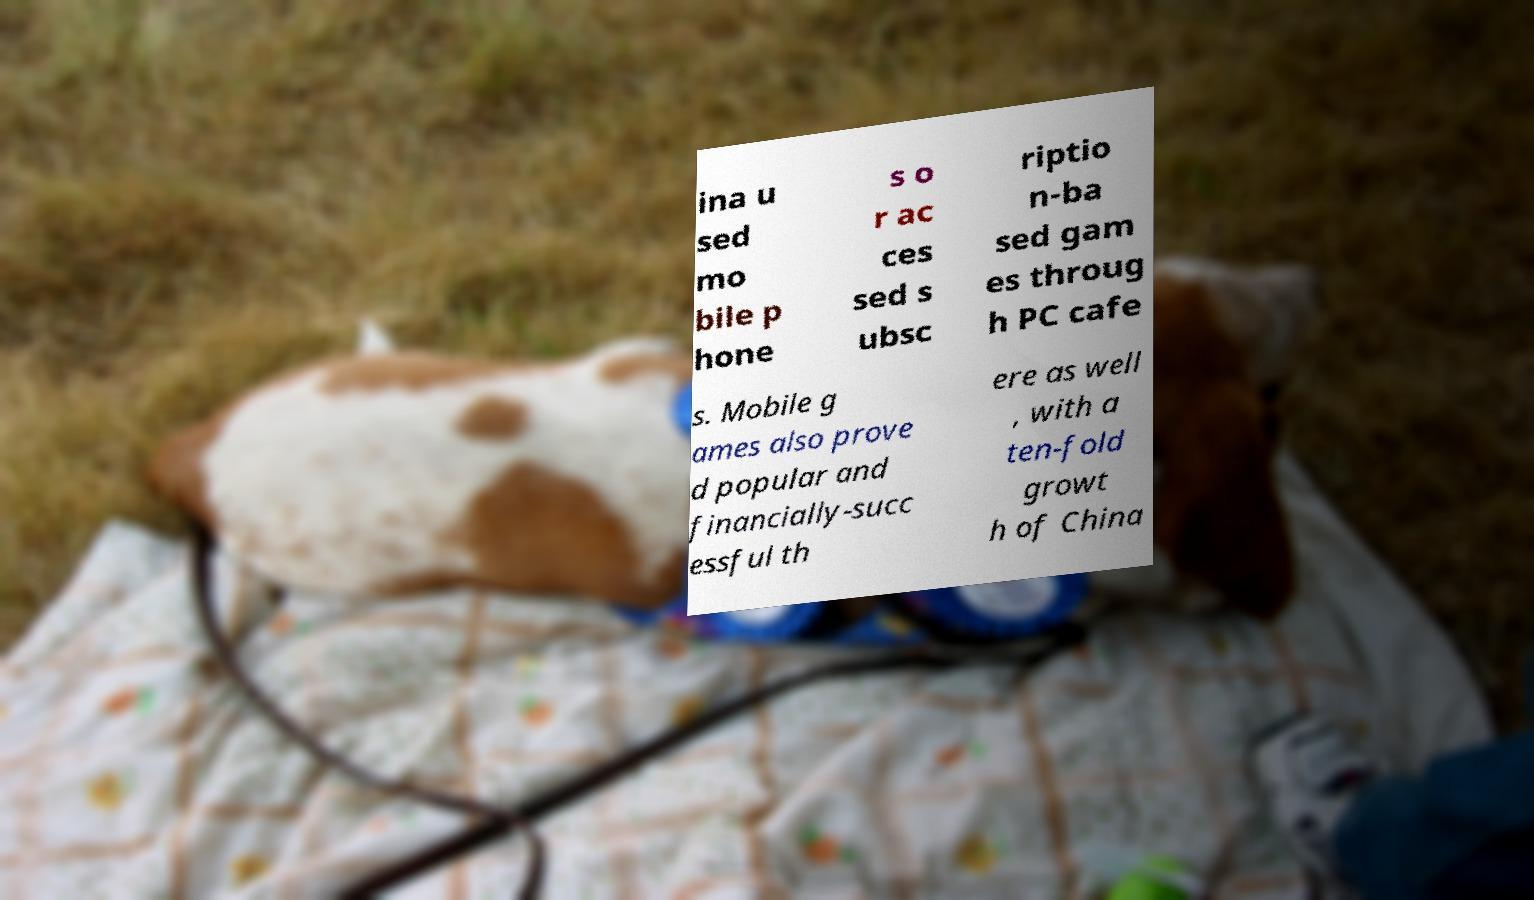Can you accurately transcribe the text from the provided image for me? ina u sed mo bile p hone s o r ac ces sed s ubsc riptio n-ba sed gam es throug h PC cafe s. Mobile g ames also prove d popular and financially-succ essful th ere as well , with a ten-fold growt h of China 